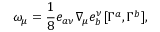<formula> <loc_0><loc_0><loc_500><loc_500>\omega _ { \mu } = \frac { 1 } { 8 } e _ { a \nu } \nabla _ { \mu } e _ { b } ^ { \nu } [ \Gamma ^ { a } , \Gamma ^ { b } ] ,</formula> 